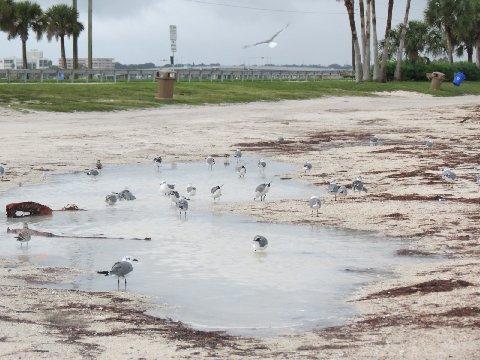How many birds are in the photo?
Give a very brief answer. 1. 